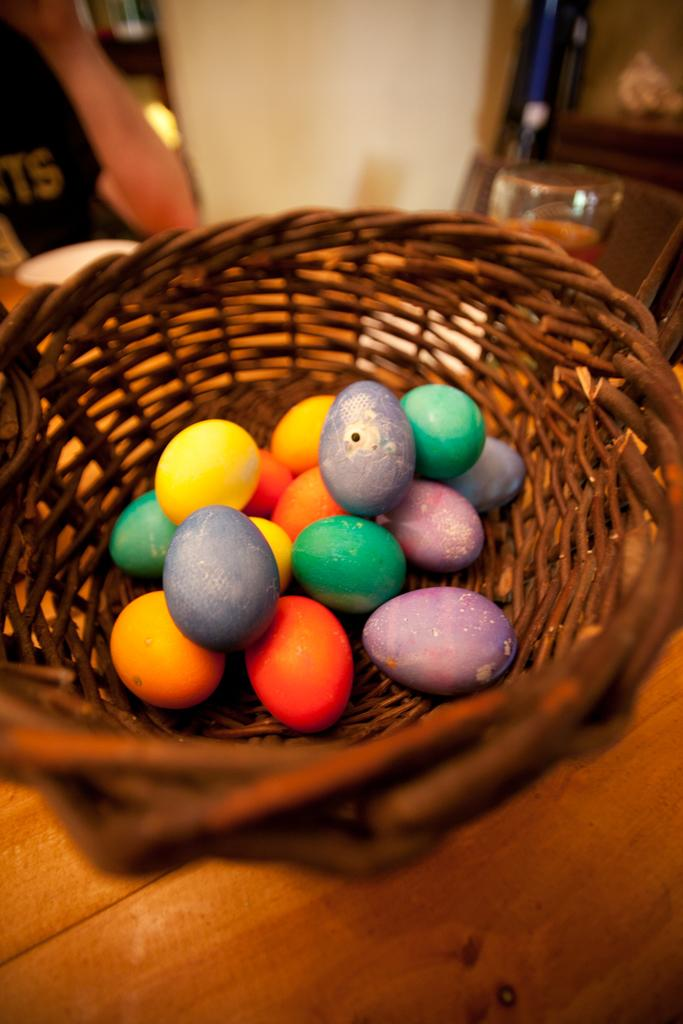What object is present in the image that can hold items? There is a basket in the image. What is inside the basket? There are eggs in the basket. Can you describe the top part of the image? The top part of the image is blurred. What day of the week is depicted in the image? The image does not depict a specific day of the week. What type of loss is shown in the image? There is no loss depicted in the image; it features a basket with eggs. 